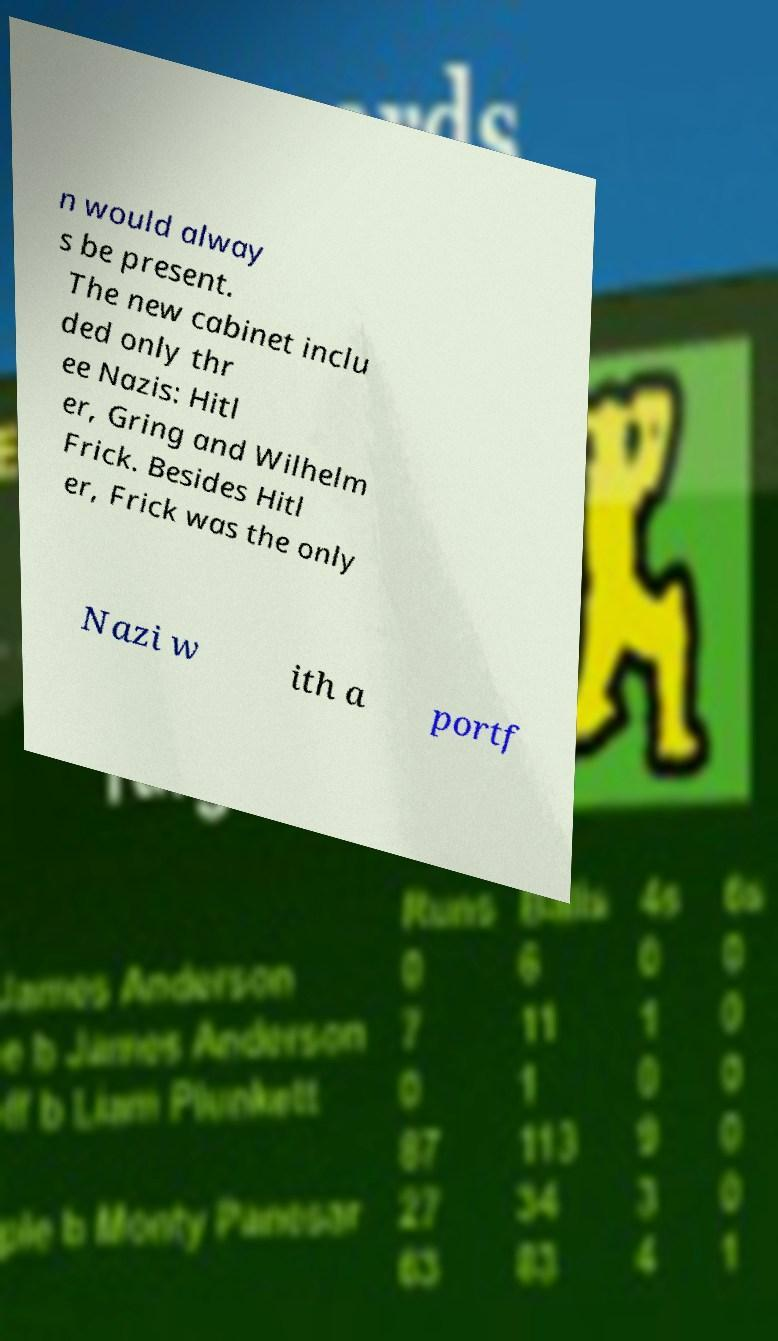I need the written content from this picture converted into text. Can you do that? n would alway s be present. The new cabinet inclu ded only thr ee Nazis: Hitl er, Gring and Wilhelm Frick. Besides Hitl er, Frick was the only Nazi w ith a portf 